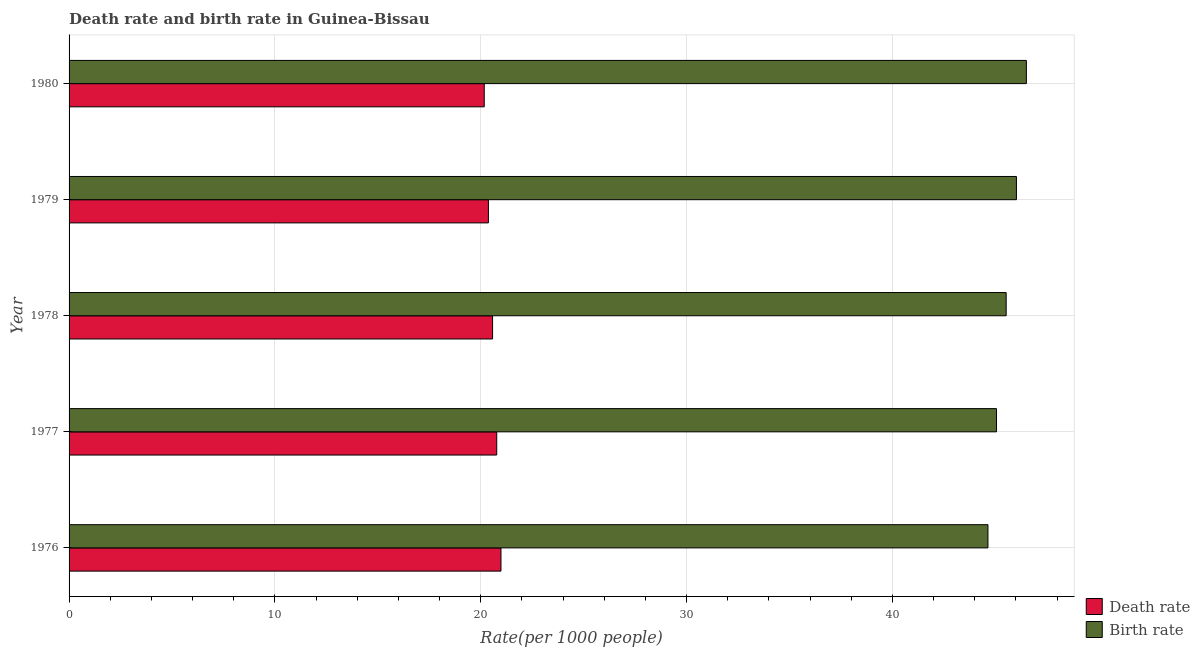Are the number of bars on each tick of the Y-axis equal?
Ensure brevity in your answer.  Yes. How many bars are there on the 5th tick from the top?
Your answer should be compact. 2. How many bars are there on the 5th tick from the bottom?
Your answer should be compact. 2. What is the label of the 2nd group of bars from the top?
Offer a very short reply. 1979. In how many cases, is the number of bars for a given year not equal to the number of legend labels?
Your answer should be compact. 0. What is the death rate in 1979?
Offer a terse response. 20.37. Across all years, what is the maximum birth rate?
Make the answer very short. 46.51. Across all years, what is the minimum birth rate?
Your answer should be very brief. 44.64. In which year was the death rate maximum?
Provide a short and direct response. 1976. In which year was the death rate minimum?
Your answer should be compact. 1980. What is the total death rate in the graph?
Make the answer very short. 102.88. What is the difference between the birth rate in 1977 and that in 1980?
Provide a succinct answer. -1.45. What is the difference between the death rate in 1976 and the birth rate in 1979?
Your answer should be compact. -25.04. What is the average death rate per year?
Provide a short and direct response. 20.58. In the year 1976, what is the difference between the birth rate and death rate?
Provide a succinct answer. 23.66. In how many years, is the birth rate greater than 46 ?
Ensure brevity in your answer.  2. What is the ratio of the death rate in 1976 to that in 1977?
Offer a terse response. 1.01. Is the difference between the death rate in 1978 and 1979 greater than the difference between the birth rate in 1978 and 1979?
Make the answer very short. Yes. What is the difference between the highest and the second highest birth rate?
Make the answer very short. 0.48. What is the difference between the highest and the lowest birth rate?
Offer a very short reply. 1.87. In how many years, is the death rate greater than the average death rate taken over all years?
Keep it short and to the point. 2. Is the sum of the birth rate in 1976 and 1980 greater than the maximum death rate across all years?
Give a very brief answer. Yes. What does the 2nd bar from the top in 1980 represents?
Give a very brief answer. Death rate. What does the 2nd bar from the bottom in 1977 represents?
Provide a short and direct response. Birth rate. Are all the bars in the graph horizontal?
Make the answer very short. Yes. How many years are there in the graph?
Provide a short and direct response. 5. Are the values on the major ticks of X-axis written in scientific E-notation?
Give a very brief answer. No. Does the graph contain any zero values?
Your response must be concise. No. Does the graph contain grids?
Ensure brevity in your answer.  Yes. Where does the legend appear in the graph?
Offer a very short reply. Bottom right. How many legend labels are there?
Offer a very short reply. 2. How are the legend labels stacked?
Provide a short and direct response. Vertical. What is the title of the graph?
Provide a short and direct response. Death rate and birth rate in Guinea-Bissau. Does "Private funds" appear as one of the legend labels in the graph?
Your answer should be very brief. No. What is the label or title of the X-axis?
Offer a very short reply. Rate(per 1000 people). What is the label or title of the Y-axis?
Provide a succinct answer. Year. What is the Rate(per 1000 people) of Death rate in 1976?
Your answer should be compact. 20.98. What is the Rate(per 1000 people) of Birth rate in 1976?
Your response must be concise. 44.64. What is the Rate(per 1000 people) of Death rate in 1977?
Keep it short and to the point. 20.78. What is the Rate(per 1000 people) of Birth rate in 1977?
Give a very brief answer. 45.06. What is the Rate(per 1000 people) of Death rate in 1978?
Your answer should be compact. 20.57. What is the Rate(per 1000 people) of Birth rate in 1978?
Ensure brevity in your answer.  45.53. What is the Rate(per 1000 people) of Death rate in 1979?
Offer a very short reply. 20.37. What is the Rate(per 1000 people) in Birth rate in 1979?
Your answer should be compact. 46.03. What is the Rate(per 1000 people) of Death rate in 1980?
Offer a very short reply. 20.17. What is the Rate(per 1000 people) in Birth rate in 1980?
Provide a short and direct response. 46.51. Across all years, what is the maximum Rate(per 1000 people) in Death rate?
Your answer should be compact. 20.98. Across all years, what is the maximum Rate(per 1000 people) in Birth rate?
Give a very brief answer. 46.51. Across all years, what is the minimum Rate(per 1000 people) of Death rate?
Offer a terse response. 20.17. Across all years, what is the minimum Rate(per 1000 people) of Birth rate?
Make the answer very short. 44.64. What is the total Rate(per 1000 people) in Death rate in the graph?
Ensure brevity in your answer.  102.88. What is the total Rate(per 1000 people) in Birth rate in the graph?
Ensure brevity in your answer.  227.76. What is the difference between the Rate(per 1000 people) in Death rate in 1976 and that in 1977?
Make the answer very short. 0.21. What is the difference between the Rate(per 1000 people) in Birth rate in 1976 and that in 1977?
Offer a terse response. -0.42. What is the difference between the Rate(per 1000 people) in Death rate in 1976 and that in 1978?
Give a very brief answer. 0.41. What is the difference between the Rate(per 1000 people) in Birth rate in 1976 and that in 1978?
Provide a short and direct response. -0.89. What is the difference between the Rate(per 1000 people) in Death rate in 1976 and that in 1979?
Your response must be concise. 0.61. What is the difference between the Rate(per 1000 people) of Birth rate in 1976 and that in 1979?
Your response must be concise. -1.38. What is the difference between the Rate(per 1000 people) in Death rate in 1976 and that in 1980?
Make the answer very short. 0.81. What is the difference between the Rate(per 1000 people) of Birth rate in 1976 and that in 1980?
Provide a succinct answer. -1.87. What is the difference between the Rate(per 1000 people) of Death rate in 1977 and that in 1978?
Your answer should be compact. 0.2. What is the difference between the Rate(per 1000 people) of Birth rate in 1977 and that in 1978?
Offer a very short reply. -0.47. What is the difference between the Rate(per 1000 people) in Death rate in 1977 and that in 1979?
Offer a very short reply. 0.4. What is the difference between the Rate(per 1000 people) of Birth rate in 1977 and that in 1979?
Keep it short and to the point. -0.97. What is the difference between the Rate(per 1000 people) in Death rate in 1977 and that in 1980?
Offer a very short reply. 0.61. What is the difference between the Rate(per 1000 people) in Birth rate in 1977 and that in 1980?
Offer a very short reply. -1.45. What is the difference between the Rate(per 1000 people) in Death rate in 1978 and that in 1979?
Provide a succinct answer. 0.2. What is the difference between the Rate(per 1000 people) in Birth rate in 1978 and that in 1979?
Offer a terse response. -0.5. What is the difference between the Rate(per 1000 people) in Death rate in 1978 and that in 1980?
Offer a terse response. 0.4. What is the difference between the Rate(per 1000 people) of Birth rate in 1978 and that in 1980?
Your answer should be very brief. -0.98. What is the difference between the Rate(per 1000 people) in Death rate in 1979 and that in 1980?
Offer a terse response. 0.2. What is the difference between the Rate(per 1000 people) in Birth rate in 1979 and that in 1980?
Provide a succinct answer. -0.48. What is the difference between the Rate(per 1000 people) of Death rate in 1976 and the Rate(per 1000 people) of Birth rate in 1977?
Your answer should be very brief. -24.07. What is the difference between the Rate(per 1000 people) of Death rate in 1976 and the Rate(per 1000 people) of Birth rate in 1978?
Offer a terse response. -24.54. What is the difference between the Rate(per 1000 people) in Death rate in 1976 and the Rate(per 1000 people) in Birth rate in 1979?
Make the answer very short. -25.04. What is the difference between the Rate(per 1000 people) in Death rate in 1976 and the Rate(per 1000 people) in Birth rate in 1980?
Your answer should be very brief. -25.53. What is the difference between the Rate(per 1000 people) in Death rate in 1977 and the Rate(per 1000 people) in Birth rate in 1978?
Ensure brevity in your answer.  -24.75. What is the difference between the Rate(per 1000 people) in Death rate in 1977 and the Rate(per 1000 people) in Birth rate in 1979?
Provide a short and direct response. -25.25. What is the difference between the Rate(per 1000 people) of Death rate in 1977 and the Rate(per 1000 people) of Birth rate in 1980?
Your response must be concise. -25.73. What is the difference between the Rate(per 1000 people) of Death rate in 1978 and the Rate(per 1000 people) of Birth rate in 1979?
Give a very brief answer. -25.45. What is the difference between the Rate(per 1000 people) in Death rate in 1978 and the Rate(per 1000 people) in Birth rate in 1980?
Offer a very short reply. -25.93. What is the difference between the Rate(per 1000 people) in Death rate in 1979 and the Rate(per 1000 people) in Birth rate in 1980?
Your response must be concise. -26.14. What is the average Rate(per 1000 people) in Death rate per year?
Make the answer very short. 20.58. What is the average Rate(per 1000 people) in Birth rate per year?
Offer a very short reply. 45.55. In the year 1976, what is the difference between the Rate(per 1000 people) in Death rate and Rate(per 1000 people) in Birth rate?
Ensure brevity in your answer.  -23.66. In the year 1977, what is the difference between the Rate(per 1000 people) of Death rate and Rate(per 1000 people) of Birth rate?
Give a very brief answer. -24.28. In the year 1978, what is the difference between the Rate(per 1000 people) of Death rate and Rate(per 1000 people) of Birth rate?
Your response must be concise. -24.95. In the year 1979, what is the difference between the Rate(per 1000 people) of Death rate and Rate(per 1000 people) of Birth rate?
Offer a very short reply. -25.65. In the year 1980, what is the difference between the Rate(per 1000 people) of Death rate and Rate(per 1000 people) of Birth rate?
Give a very brief answer. -26.34. What is the ratio of the Rate(per 1000 people) in Death rate in 1976 to that in 1977?
Provide a short and direct response. 1.01. What is the ratio of the Rate(per 1000 people) in Birth rate in 1976 to that in 1977?
Provide a succinct answer. 0.99. What is the ratio of the Rate(per 1000 people) in Death rate in 1976 to that in 1978?
Provide a succinct answer. 1.02. What is the ratio of the Rate(per 1000 people) of Birth rate in 1976 to that in 1978?
Offer a very short reply. 0.98. What is the ratio of the Rate(per 1000 people) of Death rate in 1976 to that in 1979?
Provide a short and direct response. 1.03. What is the ratio of the Rate(per 1000 people) of Birth rate in 1976 to that in 1979?
Provide a succinct answer. 0.97. What is the ratio of the Rate(per 1000 people) in Death rate in 1976 to that in 1980?
Make the answer very short. 1.04. What is the ratio of the Rate(per 1000 people) of Birth rate in 1976 to that in 1980?
Offer a terse response. 0.96. What is the ratio of the Rate(per 1000 people) in Death rate in 1977 to that in 1978?
Your answer should be compact. 1.01. What is the ratio of the Rate(per 1000 people) of Birth rate in 1977 to that in 1978?
Provide a succinct answer. 0.99. What is the ratio of the Rate(per 1000 people) in Death rate in 1977 to that in 1979?
Offer a terse response. 1.02. What is the ratio of the Rate(per 1000 people) in Birth rate in 1977 to that in 1979?
Keep it short and to the point. 0.98. What is the ratio of the Rate(per 1000 people) in Birth rate in 1977 to that in 1980?
Your response must be concise. 0.97. What is the ratio of the Rate(per 1000 people) in Death rate in 1978 to that in 1979?
Offer a very short reply. 1.01. What is the ratio of the Rate(per 1000 people) in Birth rate in 1978 to that in 1979?
Provide a short and direct response. 0.99. What is the ratio of the Rate(per 1000 people) in Birth rate in 1978 to that in 1980?
Keep it short and to the point. 0.98. What is the ratio of the Rate(per 1000 people) in Birth rate in 1979 to that in 1980?
Ensure brevity in your answer.  0.99. What is the difference between the highest and the second highest Rate(per 1000 people) of Death rate?
Offer a very short reply. 0.21. What is the difference between the highest and the second highest Rate(per 1000 people) of Birth rate?
Your answer should be very brief. 0.48. What is the difference between the highest and the lowest Rate(per 1000 people) in Death rate?
Provide a succinct answer. 0.81. What is the difference between the highest and the lowest Rate(per 1000 people) in Birth rate?
Your answer should be very brief. 1.87. 